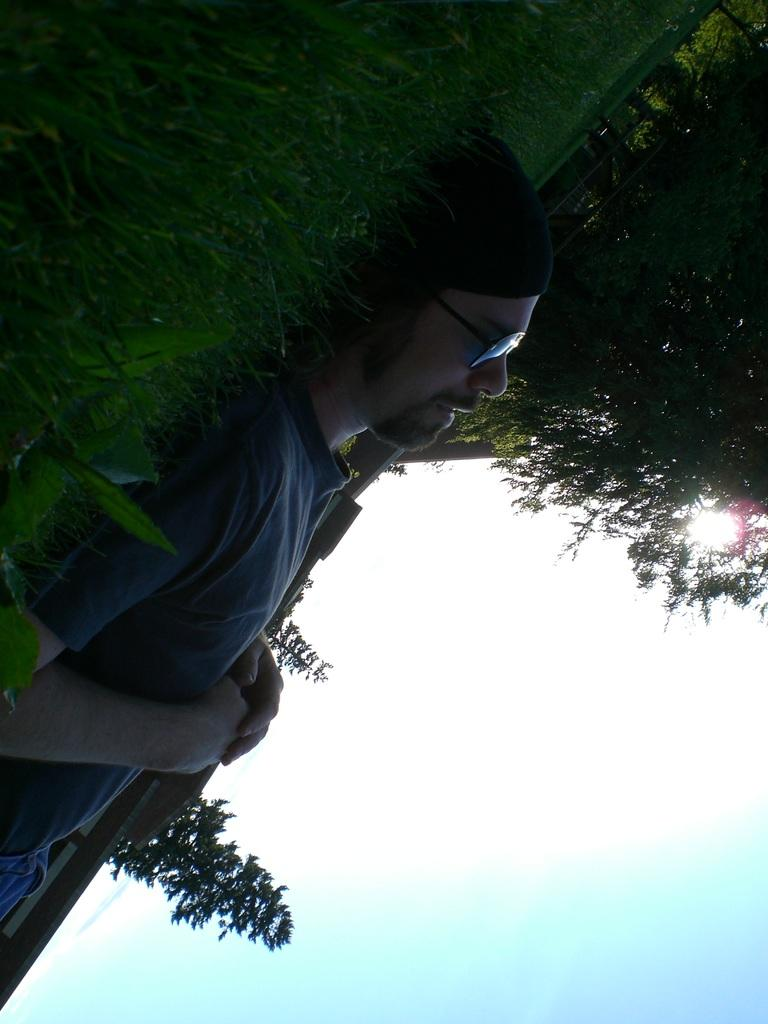Who is present in the image? There is a man in the image. What is the man wearing on his head? The man is wearing a cap. What is the man's position in the image? The man is lying on the grass. What type of vegetation can be seen in the image? There are trees in the image. What structure is visible in the image? There is a wall in the image. What is visible in the background of the image? The sky is visible in the background of the image. How many cherries can be seen on the man's fang in the image? There are no cherries or fangs present in the image; it features a man lying on the grass with a cap on his head. 